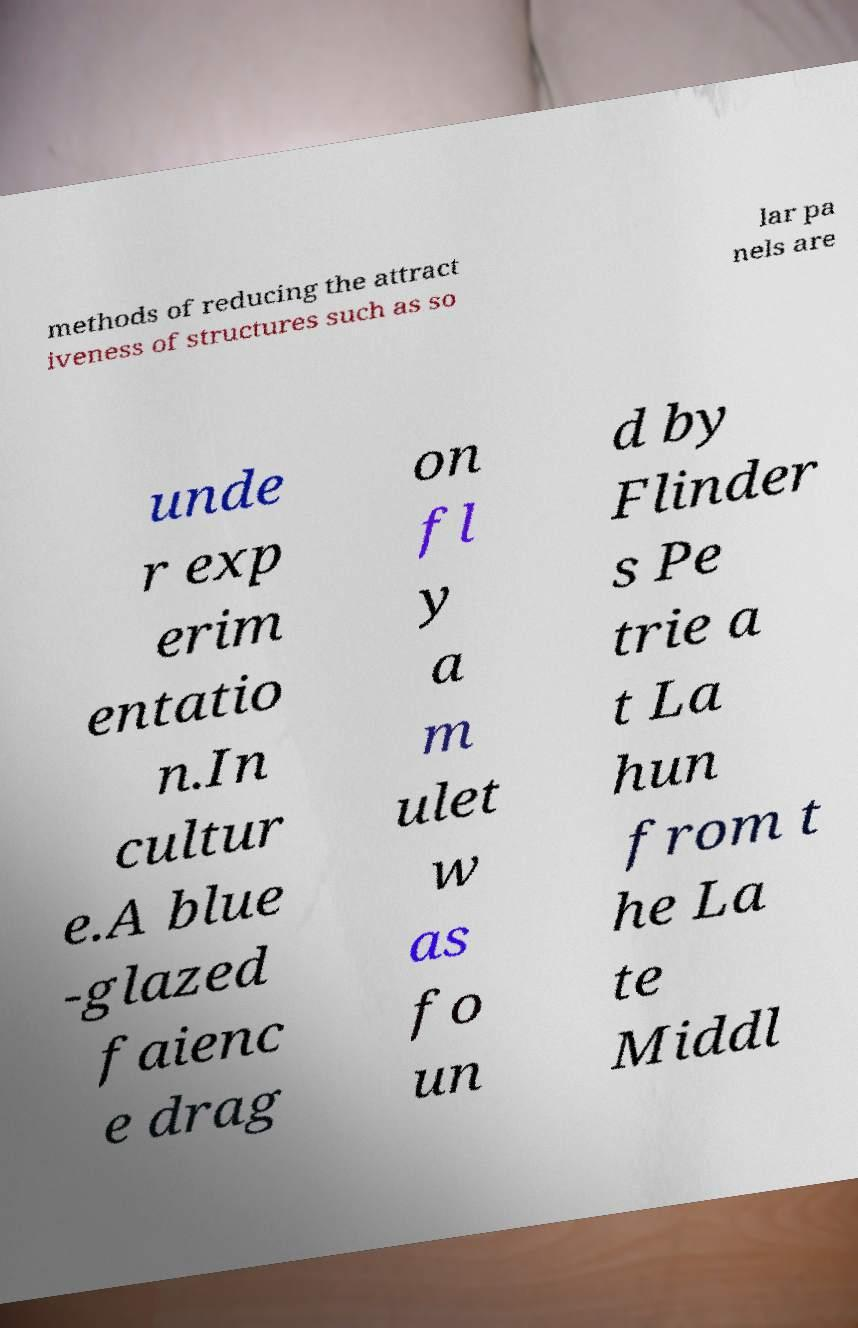What messages or text are displayed in this image? I need them in a readable, typed format. methods of reducing the attract iveness of structures such as so lar pa nels are unde r exp erim entatio n.In cultur e.A blue -glazed faienc e drag on fl y a m ulet w as fo un d by Flinder s Pe trie a t La hun from t he La te Middl 